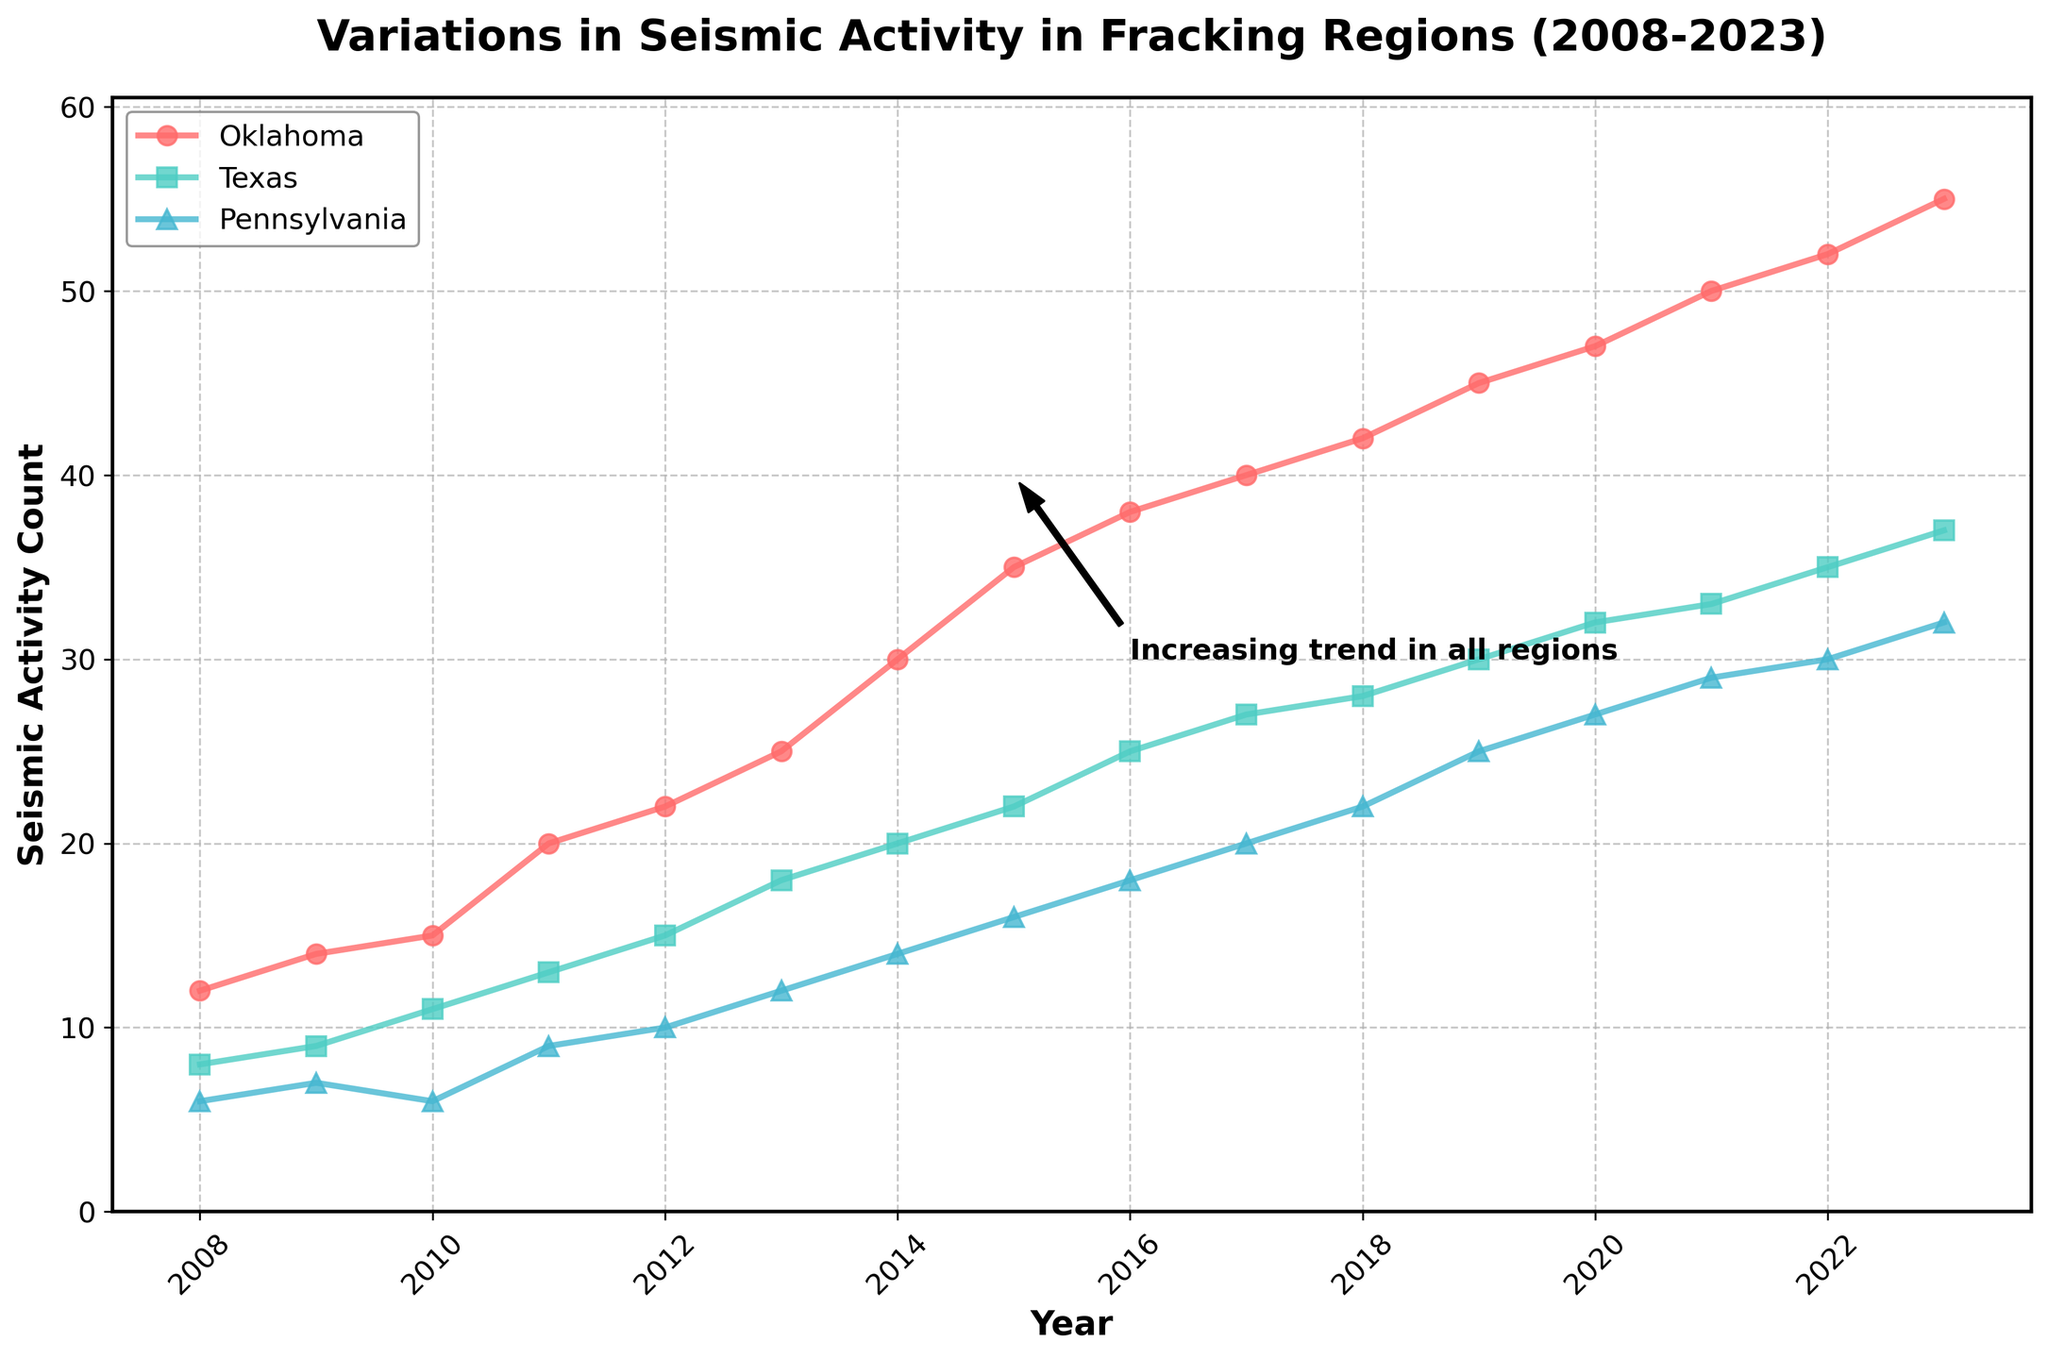What's the title of the plot? The title of the plot is usually found at the top center of the figure and it provides a summary of what the viewer is looking at. Here, it reads "Variations in Seismic Activity in Fracking Regions (2008-2023)"
Answer: Variations in Seismic Activity in Fracking Regions (2008-2023) How many regions are being compared in the plot? By looking at the legend or the different lines on the plot, we can see the regions being compared. There are three different lines labeled as Oklahoma, Texas, and Pennsylvania.
Answer: Three In which year did Oklahoma experience the highest seismic activity count? By following the line corresponding to Oklahoma to its highest point and then tracing it vertically to the x-axis, you reach the year 2023.
Answer: 2023 What trend is common across all regions displayed in the plot? The general direction of the lines for all regions helps identify the trend. All the lines are rising, indicating an increase in seismic activity over time.
Answer: Increasing trend What's the difference in seismic activity counts between Texas and Pennsylvania in 2018? First, locate the seismic activity count for Texas (28) and Pennsylvania (22) in 2018. The difference is calculated by subtraction: 28 - 22.
Answer: 6 By how much did the seismic activity count increase in Oklahoma from 2008 to 2023? Find the values for Oklahoma in 2008 (12) and 2023 (55). The increase is the difference: 55 - 12.
Answer: 43 How does the seismic activity in Pennsylvania in 2015 compare to that in Texas in the same year? Locate the values for both regions in 2015. Pennsylvania has a count of 16, while Texas has 22. Comparing them shows Texas has a higher seismic activity count.
Answer: Texas is higher What's the average seismic activity count for Pennsylvania from 2018 to 2023? Sum the seismic activity counts for Pennsylvania between 2018 to 2023 (22, 25, 27, 29, 30, 32) and divide by the number of years (6). Calculation: (22+25+27+29+30+32)/6.
Answer: 27.5 What annotation is included in the plot and where? Look for annotations or text within the figure. There's a note labeled "Increasing trend in all regions" placed near the years 2015-2016.
Answer: Increasing trend in all regions near 2015-2016 